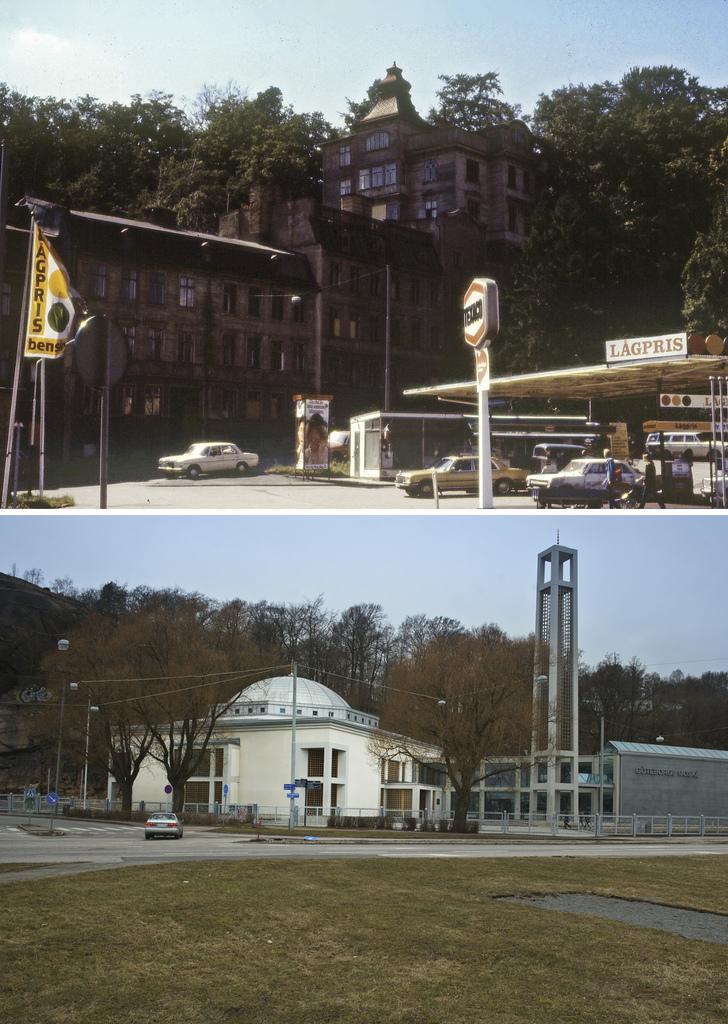How would you summarize this image in a sentence or two? The picture is the collage of two images. In the first image I can see a building, few trees and few cars. In the second picture I can see a building, a car and few trees in the background. 